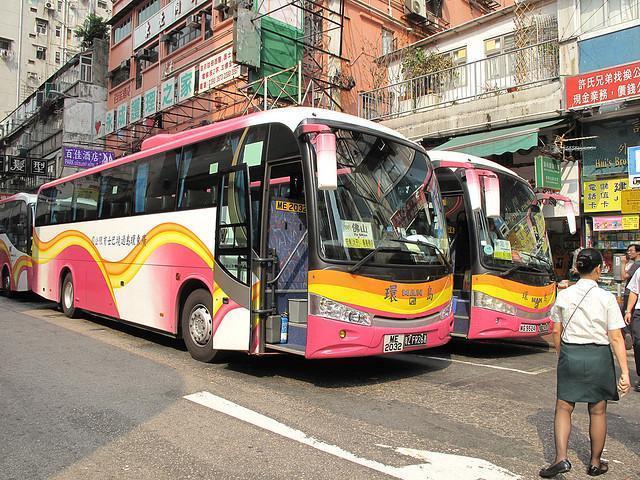How many buses can be seen?
Give a very brief answer. 3. 